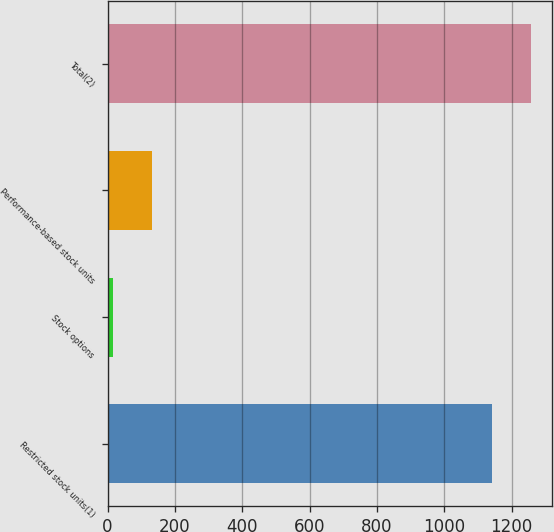Convert chart to OTSL. <chart><loc_0><loc_0><loc_500><loc_500><bar_chart><fcel>Restricted stock units(1)<fcel>Stock options<fcel>Performance-based stock units<fcel>Total(2)<nl><fcel>1140<fcel>15<fcel>131.9<fcel>1256.9<nl></chart> 